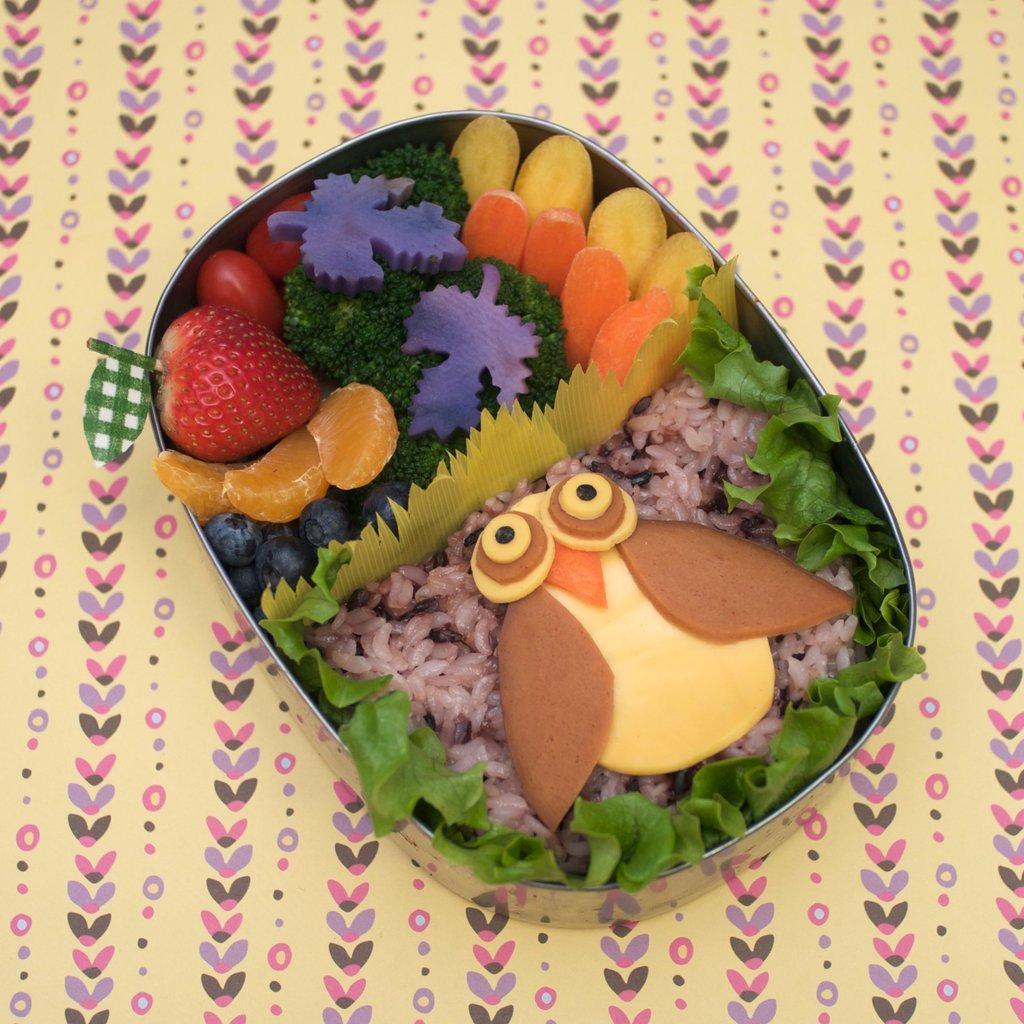Please provide a concise description of this image. This image consist of food in the bowl which is on the surface which is yellow and pink in colour. 